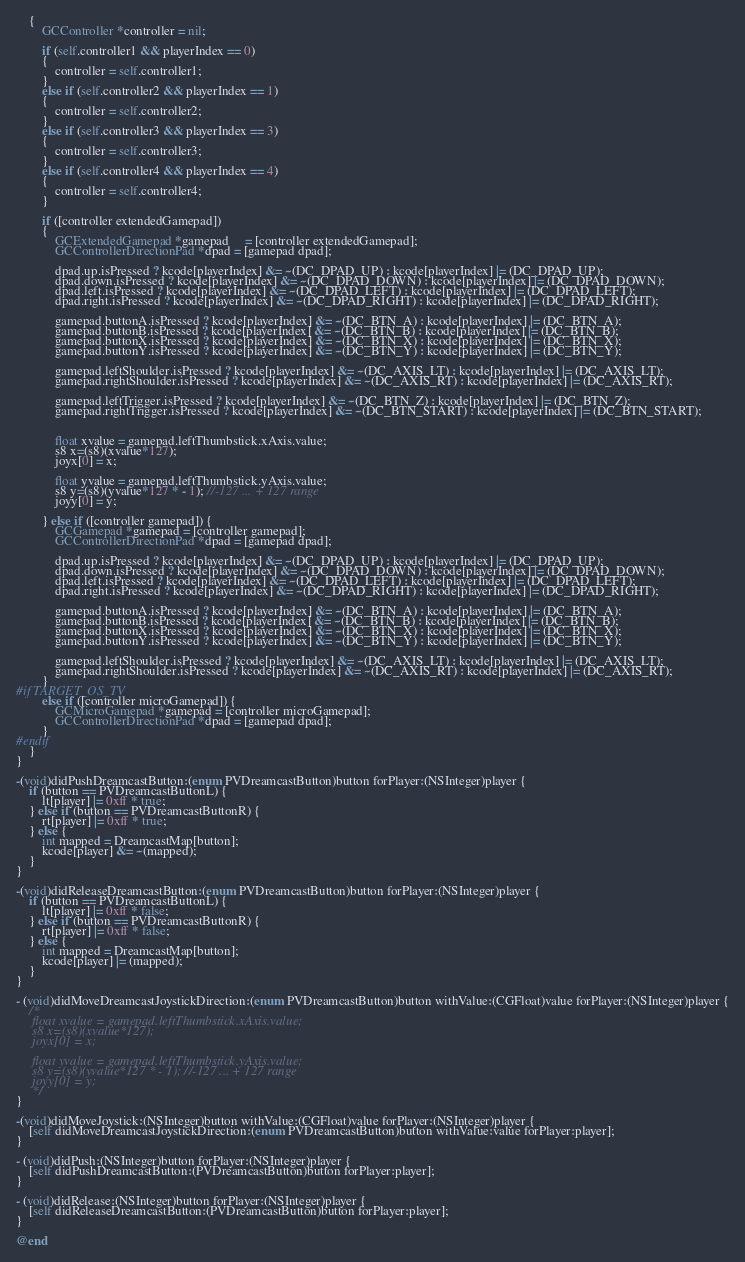<code> <loc_0><loc_0><loc_500><loc_500><_ObjectiveC_>    {
        GCController *controller = nil;

        if (self.controller1 && playerIndex == 0)
        {
            controller = self.controller1;
        }
        else if (self.controller2 && playerIndex == 1)
        {
            controller = self.controller2;
        }
        else if (self.controller3 && playerIndex == 3)
        {
            controller = self.controller3;
        }
        else if (self.controller4 && playerIndex == 4)
        {
            controller = self.controller4;
        }

        if ([controller extendedGamepad])
        {
            GCExtendedGamepad *gamepad     = [controller extendedGamepad];
            GCControllerDirectionPad *dpad = [gamepad dpad];

            dpad.up.isPressed ? kcode[playerIndex] &= ~(DC_DPAD_UP) : kcode[playerIndex] |= (DC_DPAD_UP);
            dpad.down.isPressed ? kcode[playerIndex] &= ~(DC_DPAD_DOWN) : kcode[playerIndex] |= (DC_DPAD_DOWN);
            dpad.left.isPressed ? kcode[playerIndex] &= ~(DC_DPAD_LEFT) : kcode[playerIndex] |= (DC_DPAD_LEFT);
            dpad.right.isPressed ? kcode[playerIndex] &= ~(DC_DPAD_RIGHT) : kcode[playerIndex] |= (DC_DPAD_RIGHT);

            gamepad.buttonA.isPressed ? kcode[playerIndex] &= ~(DC_BTN_A) : kcode[playerIndex] |= (DC_BTN_A);
            gamepad.buttonB.isPressed ? kcode[playerIndex] &= ~(DC_BTN_B) : kcode[playerIndex] |= (DC_BTN_B);
            gamepad.buttonX.isPressed ? kcode[playerIndex] &= ~(DC_BTN_X) : kcode[playerIndex] |= (DC_BTN_X);
            gamepad.buttonY.isPressed ? kcode[playerIndex] &= ~(DC_BTN_Y) : kcode[playerIndex] |= (DC_BTN_Y);

            gamepad.leftShoulder.isPressed ? kcode[playerIndex] &= ~(DC_AXIS_LT) : kcode[playerIndex] |= (DC_AXIS_LT);
            gamepad.rightShoulder.isPressed ? kcode[playerIndex] &= ~(DC_AXIS_RT) : kcode[playerIndex] |= (DC_AXIS_RT);

            gamepad.leftTrigger.isPressed ? kcode[playerIndex] &= ~(DC_BTN_Z) : kcode[playerIndex] |= (DC_BTN_Z);
            gamepad.rightTrigger.isPressed ? kcode[playerIndex] &= ~(DC_BTN_START) : kcode[playerIndex] |= (DC_BTN_START);


            float xvalue = gamepad.leftThumbstick.xAxis.value;
            s8 x=(s8)(xvalue*127);
            joyx[0] = x;

            float yvalue = gamepad.leftThumbstick.yAxis.value;
            s8 y=(s8)(yvalue*127 * - 1); //-127 ... + 127 range
            joyy[0] = y;

        } else if ([controller gamepad]) {
            GCGamepad *gamepad = [controller gamepad];
            GCControllerDirectionPad *dpad = [gamepad dpad];

            dpad.up.isPressed ? kcode[playerIndex] &= ~(DC_DPAD_UP) : kcode[playerIndex] |= (DC_DPAD_UP);
            dpad.down.isPressed ? kcode[playerIndex] &= ~(DC_DPAD_DOWN) : kcode[playerIndex] |= (DC_DPAD_DOWN);
            dpad.left.isPressed ? kcode[playerIndex] &= ~(DC_DPAD_LEFT) : kcode[playerIndex] |= (DC_DPAD_LEFT);
            dpad.right.isPressed ? kcode[playerIndex] &= ~(DC_DPAD_RIGHT) : kcode[playerIndex] |= (DC_DPAD_RIGHT);

            gamepad.buttonA.isPressed ? kcode[playerIndex] &= ~(DC_BTN_A) : kcode[playerIndex] |= (DC_BTN_A);
            gamepad.buttonB.isPressed ? kcode[playerIndex] &= ~(DC_BTN_B) : kcode[playerIndex] |= (DC_BTN_B);
            gamepad.buttonX.isPressed ? kcode[playerIndex] &= ~(DC_BTN_X) : kcode[playerIndex] |= (DC_BTN_X);
            gamepad.buttonY.isPressed ? kcode[playerIndex] &= ~(DC_BTN_Y) : kcode[playerIndex] |= (DC_BTN_Y);

            gamepad.leftShoulder.isPressed ? kcode[playerIndex] &= ~(DC_AXIS_LT) : kcode[playerIndex] |= (DC_AXIS_LT);
            gamepad.rightShoulder.isPressed ? kcode[playerIndex] &= ~(DC_AXIS_RT) : kcode[playerIndex] |= (DC_AXIS_RT);
        }
#if TARGET_OS_TV
        else if ([controller microGamepad]) {
            GCMicroGamepad *gamepad = [controller microGamepad];
            GCControllerDirectionPad *dpad = [gamepad dpad];
        }
#endif
    }
}

-(void)didPushDreamcastButton:(enum PVDreamcastButton)button forPlayer:(NSInteger)player {
    if (button == PVDreamcastButtonL) {
        lt[player] |= 0xff * true;
    } else if (button == PVDreamcastButtonR) {
        rt[player] |= 0xff * true;
    } else {
        int mapped = DreamcastMap[button];
        kcode[player] &= ~(mapped);
    }
}

-(void)didReleaseDreamcastButton:(enum PVDreamcastButton)button forPlayer:(NSInteger)player {
    if (button == PVDreamcastButtonL) {
        lt[player] |= 0xff * false;
    } else if (button == PVDreamcastButtonR) {
        rt[player] |= 0xff * false;
    } else {
        int mapped = DreamcastMap[button];
        kcode[player] |= (mapped);
    }
}

- (void)didMoveDreamcastJoystickDirection:(enum PVDreamcastButton)button withValue:(CGFloat)value forPlayer:(NSInteger)player {
    /*
     float xvalue = gamepad.leftThumbstick.xAxis.value;
     s8 x=(s8)(xvalue*127);
     joyx[0] = x;

     float yvalue = gamepad.leftThumbstick.yAxis.value;
     s8 y=(s8)(yvalue*127 * - 1); //-127 ... + 127 range
     joyy[0] = y;
     */
}

-(void)didMoveJoystick:(NSInteger)button withValue:(CGFloat)value forPlayer:(NSInteger)player {
    [self didMoveDreamcastJoystickDirection:(enum PVDreamcastButton)button withValue:value forPlayer:player];
}

- (void)didPush:(NSInteger)button forPlayer:(NSInteger)player {
    [self didPushDreamcastButton:(PVDreamcastButton)button forPlayer:player];
}

- (void)didRelease:(NSInteger)button forPlayer:(NSInteger)player {
    [self didReleaseDreamcastButton:(PVDreamcastButton)button forPlayer:player];
}

@end
</code> 